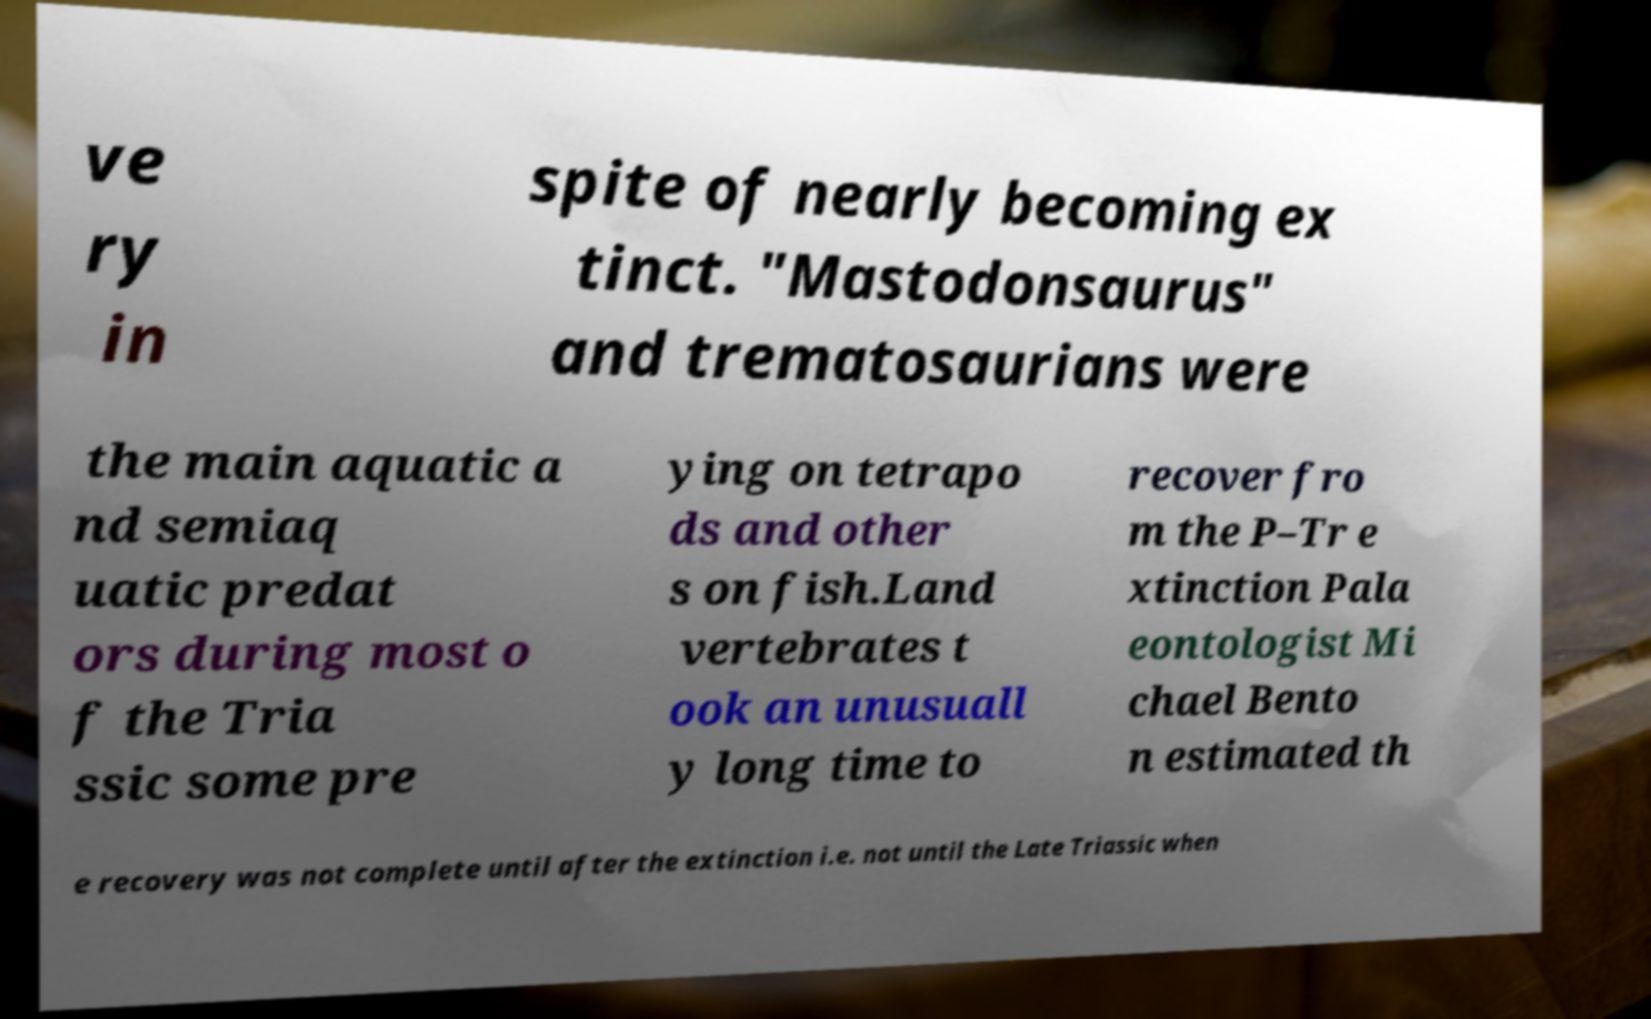Can you read and provide the text displayed in the image?This photo seems to have some interesting text. Can you extract and type it out for me? ve ry in spite of nearly becoming ex tinct. "Mastodonsaurus" and trematosaurians were the main aquatic a nd semiaq uatic predat ors during most o f the Tria ssic some pre ying on tetrapo ds and other s on fish.Land vertebrates t ook an unusuall y long time to recover fro m the P–Tr e xtinction Pala eontologist Mi chael Bento n estimated th e recovery was not complete until after the extinction i.e. not until the Late Triassic when 